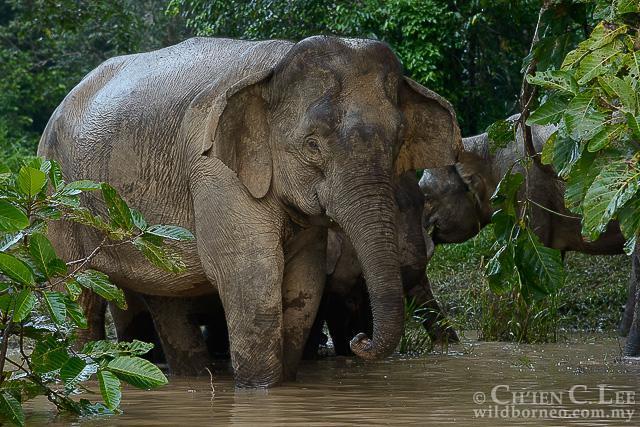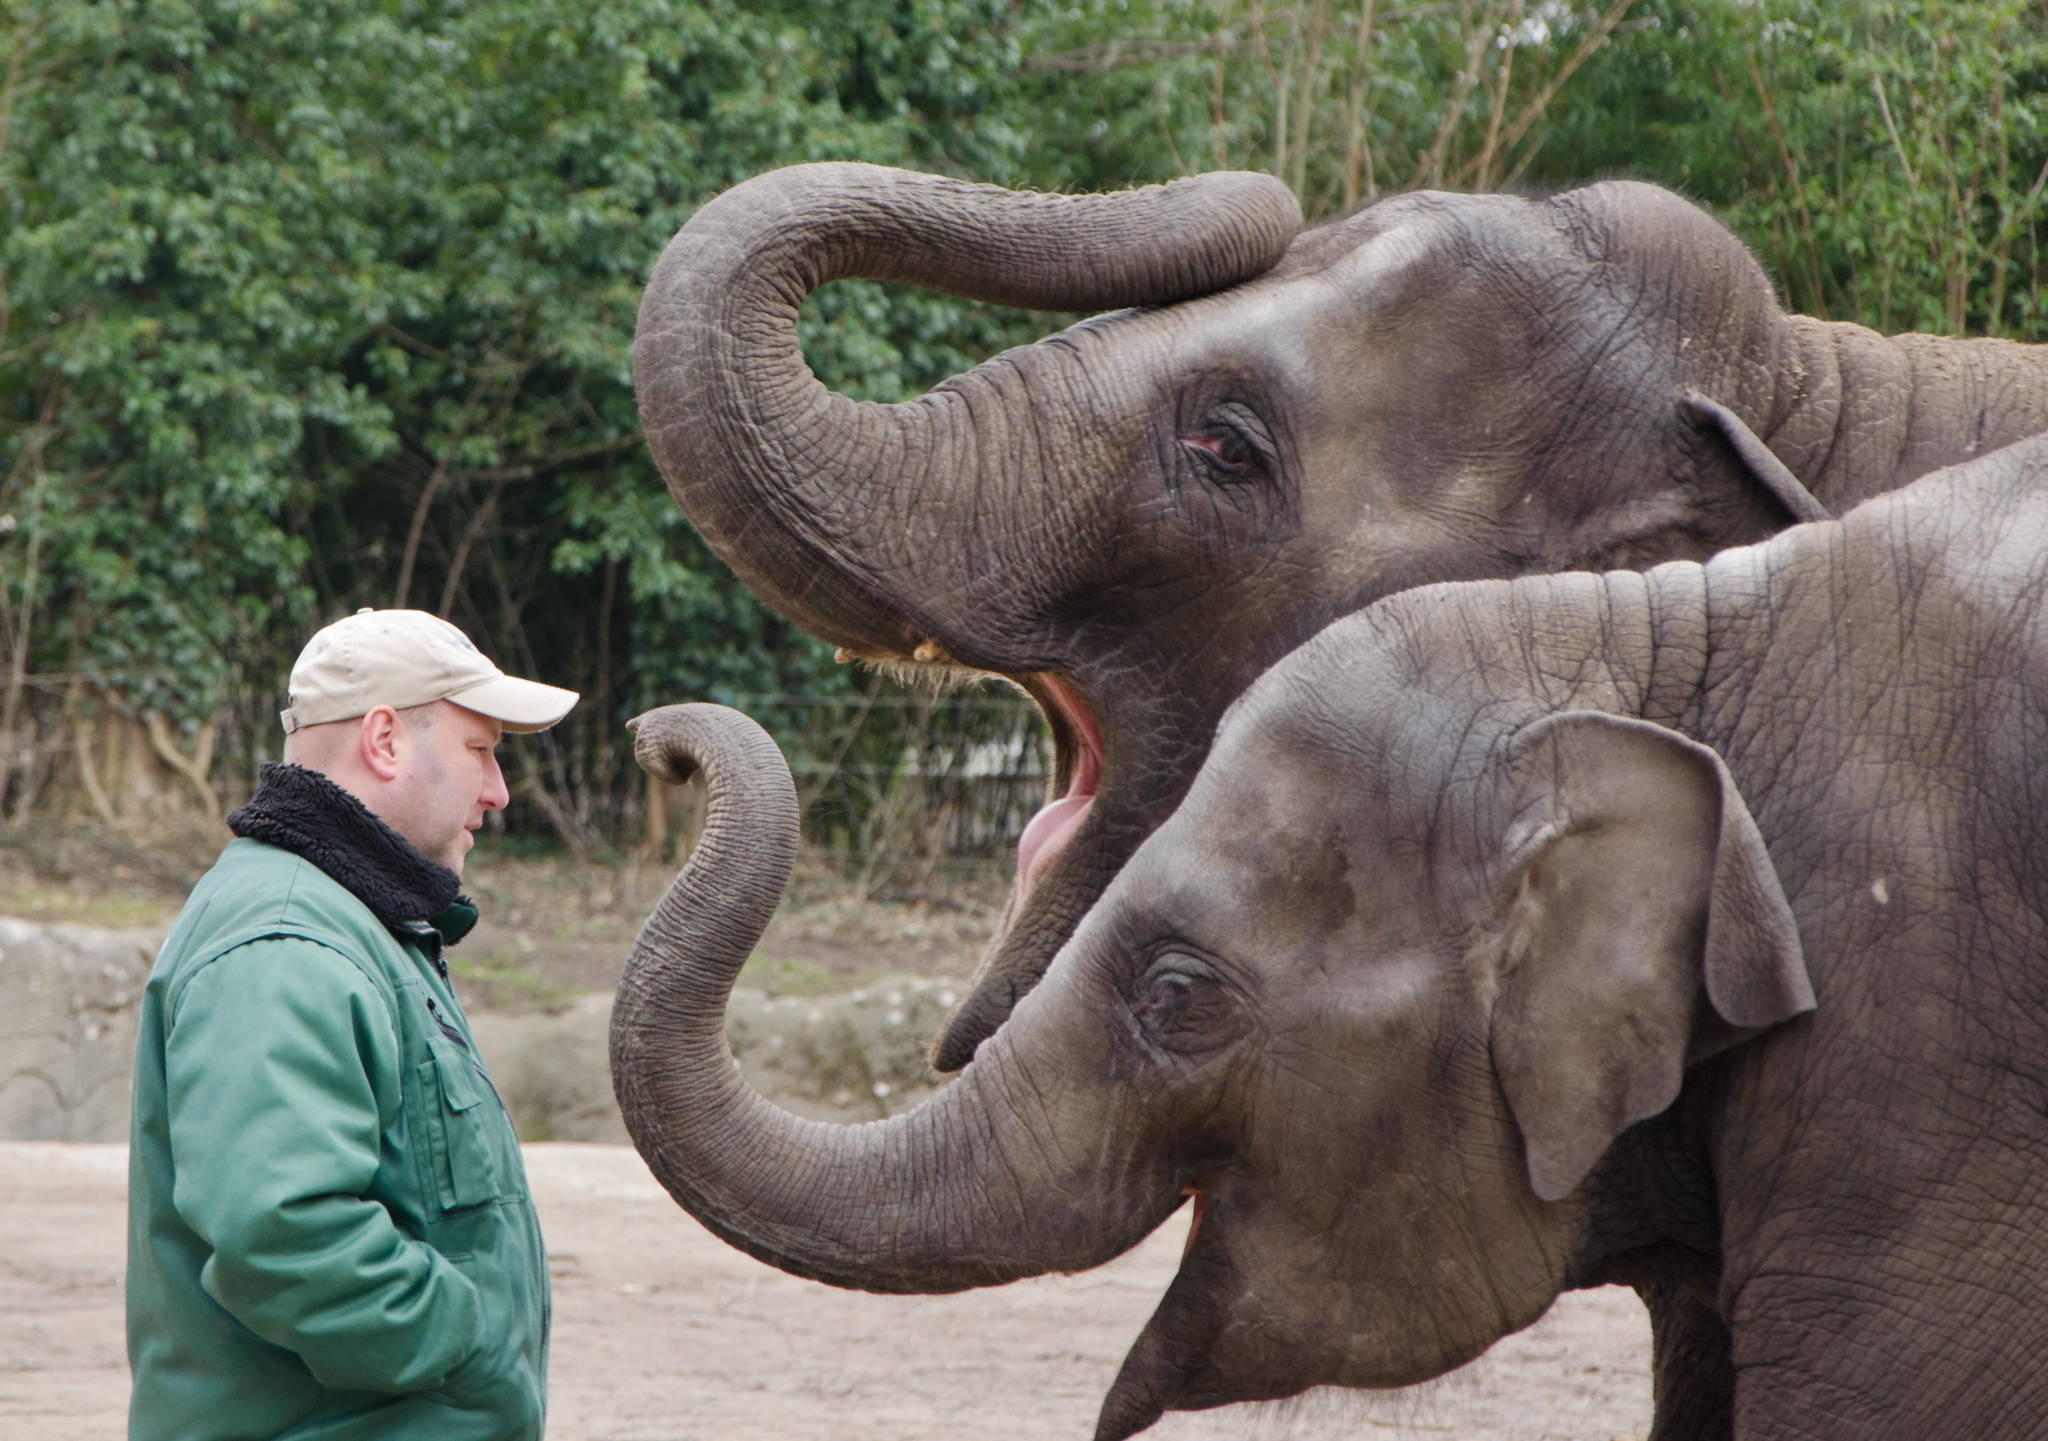The first image is the image on the left, the second image is the image on the right. Assess this claim about the two images: "One image shows only an adult elephant interacting with a young elephant while the other image shows a single elephant.". Correct or not? Answer yes or no. No. The first image is the image on the left, the second image is the image on the right. Evaluate the accuracy of this statement regarding the images: "An image shows one baby elephant standing by one adult elephant on dry land.". Is it true? Answer yes or no. No. 